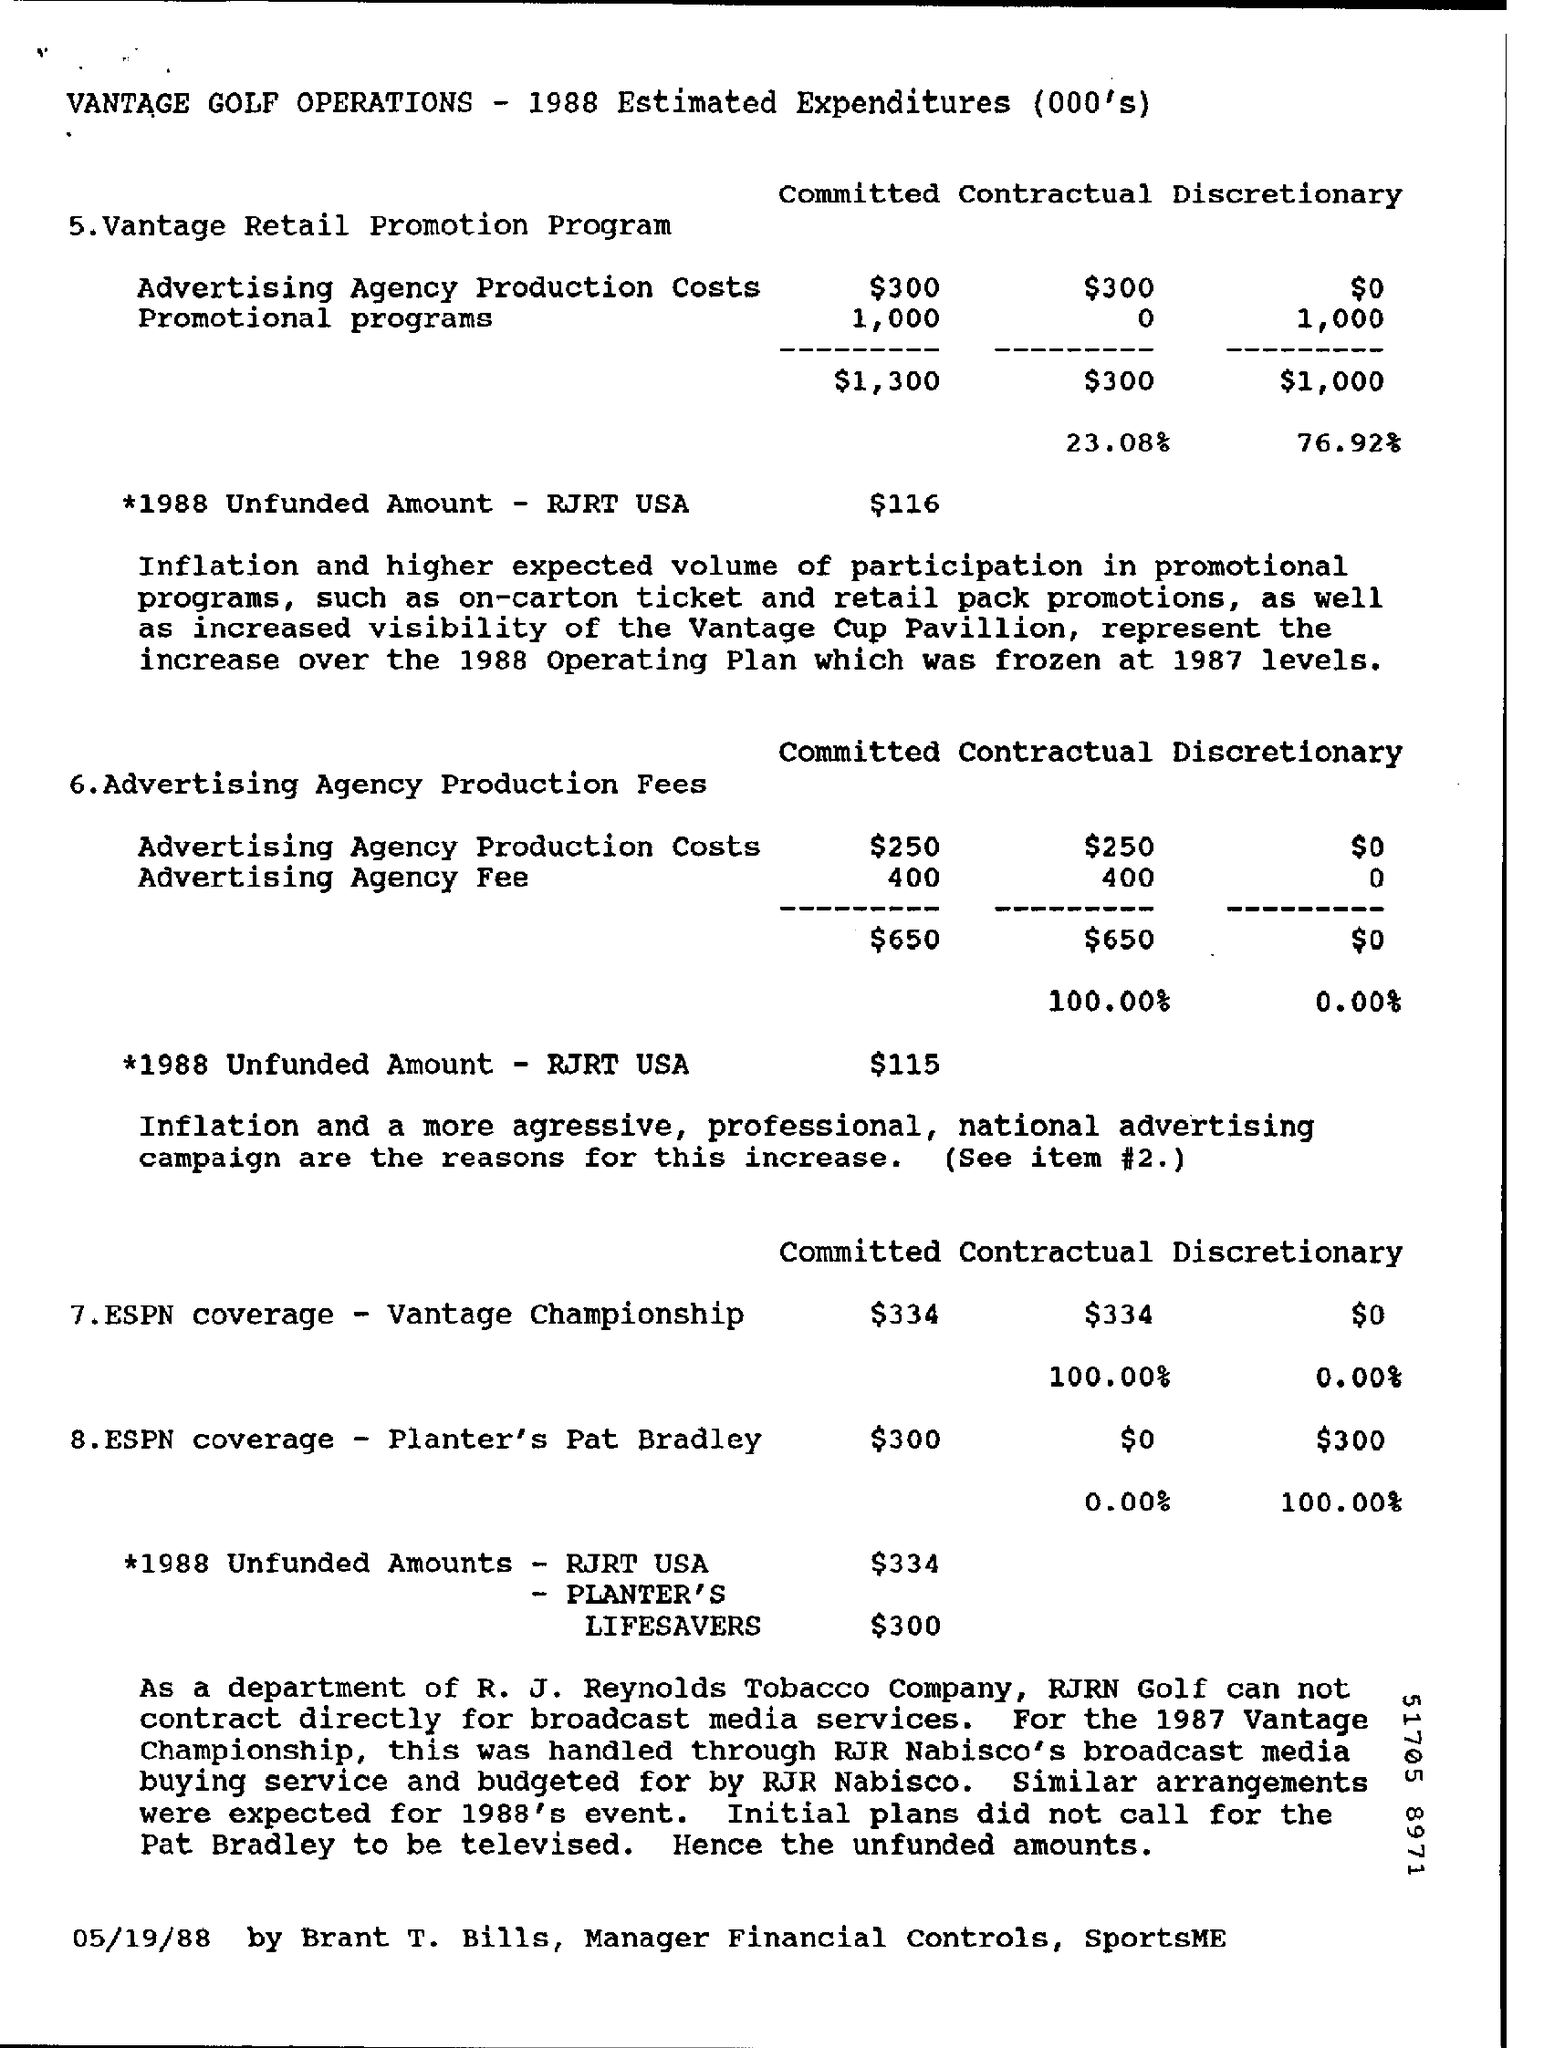Outline some significant characteristics in this image. The amount of unfunded liabilities for Planter's Lifesavers is $300. 